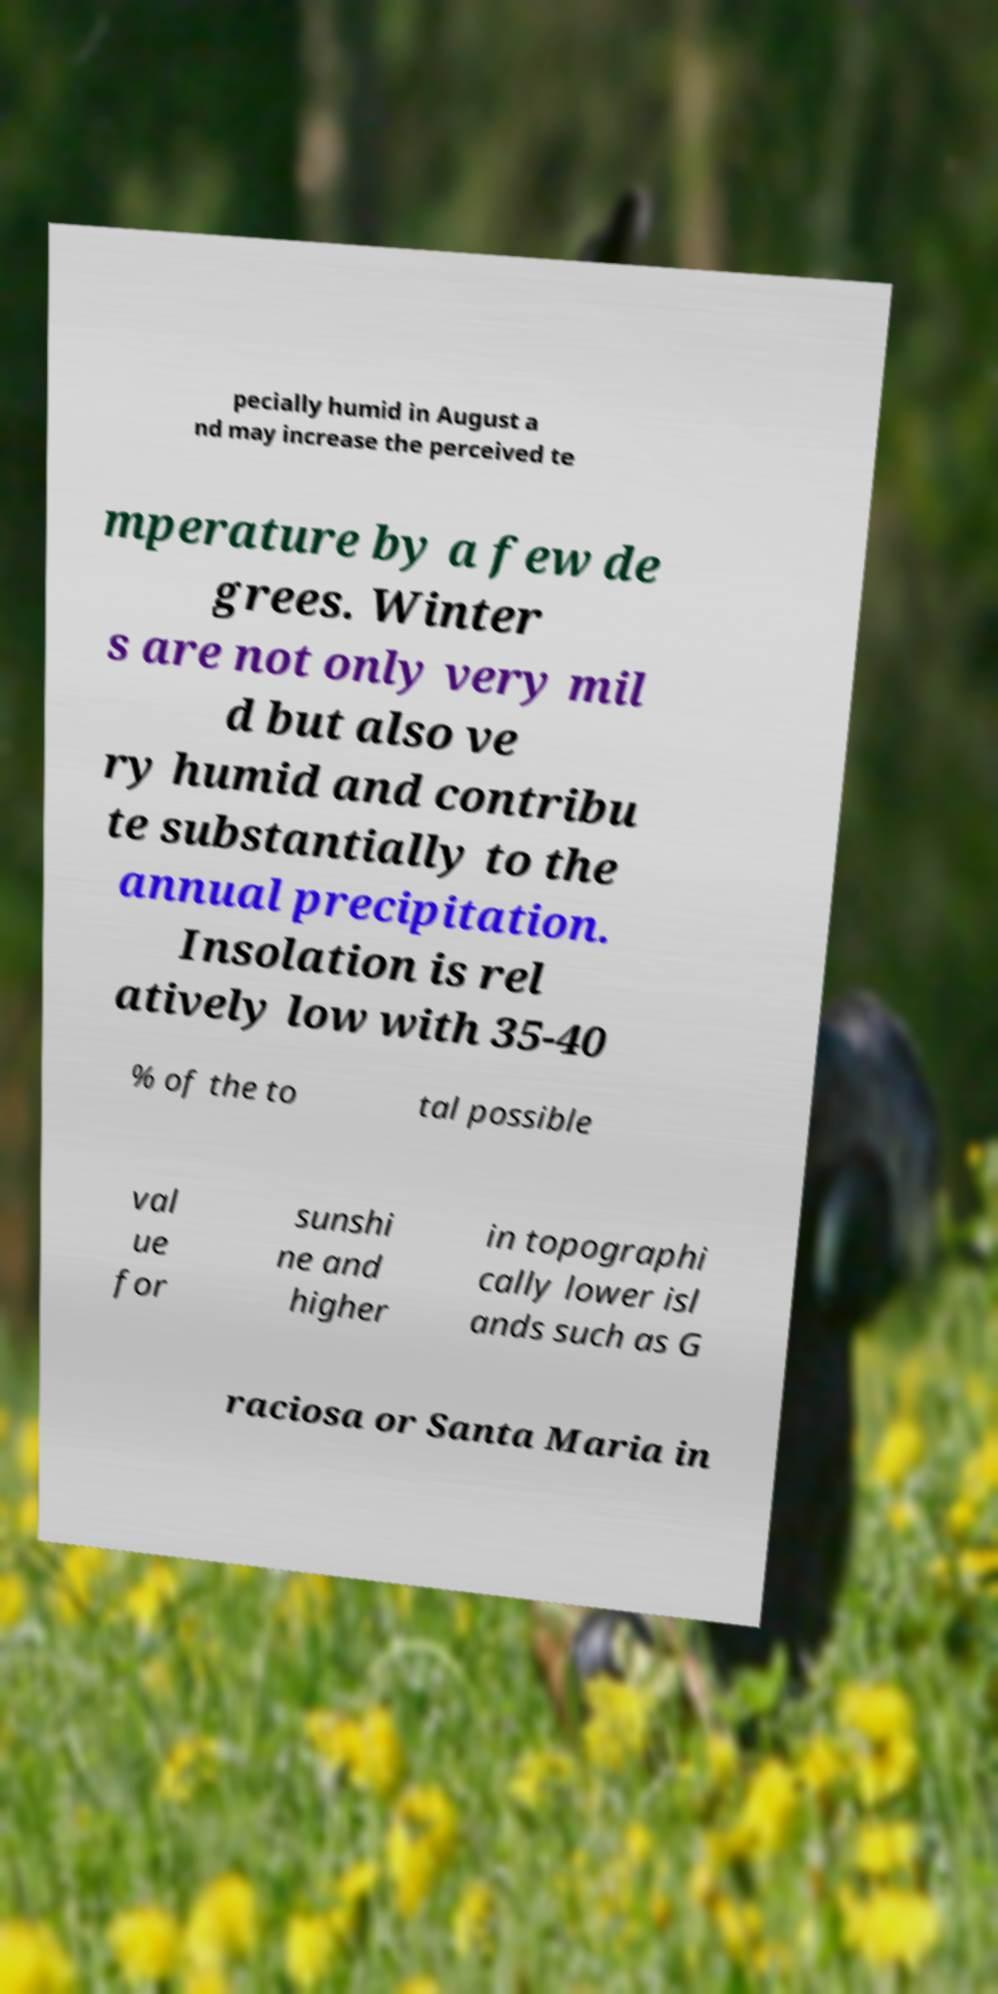There's text embedded in this image that I need extracted. Can you transcribe it verbatim? pecially humid in August a nd may increase the perceived te mperature by a few de grees. Winter s are not only very mil d but also ve ry humid and contribu te substantially to the annual precipitation. Insolation is rel atively low with 35-40 % of the to tal possible val ue for sunshi ne and higher in topographi cally lower isl ands such as G raciosa or Santa Maria in 